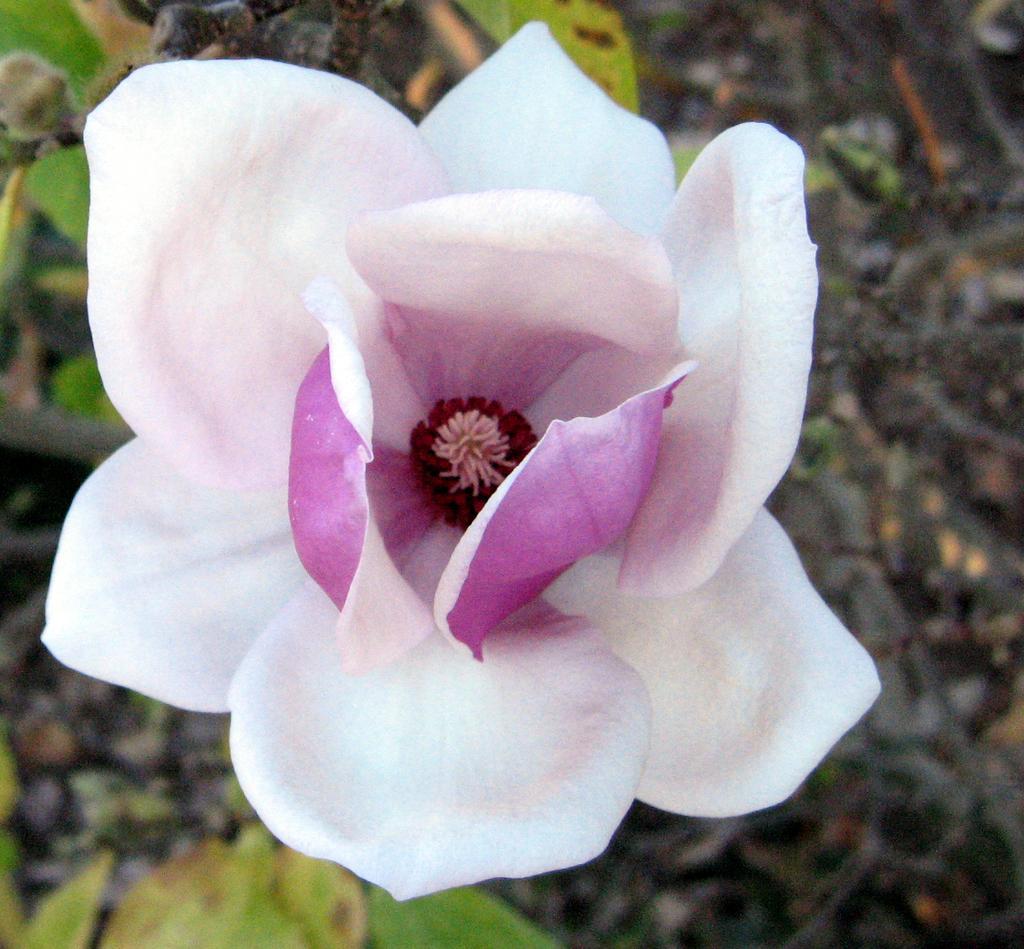Could you give a brief overview of what you see in this image? In this picture I can see the flower. 